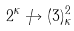Convert formula to latex. <formula><loc_0><loc_0><loc_500><loc_500>2 ^ { \kappa } \not \rightarrow ( 3 ) _ { \kappa } ^ { 2 }</formula> 